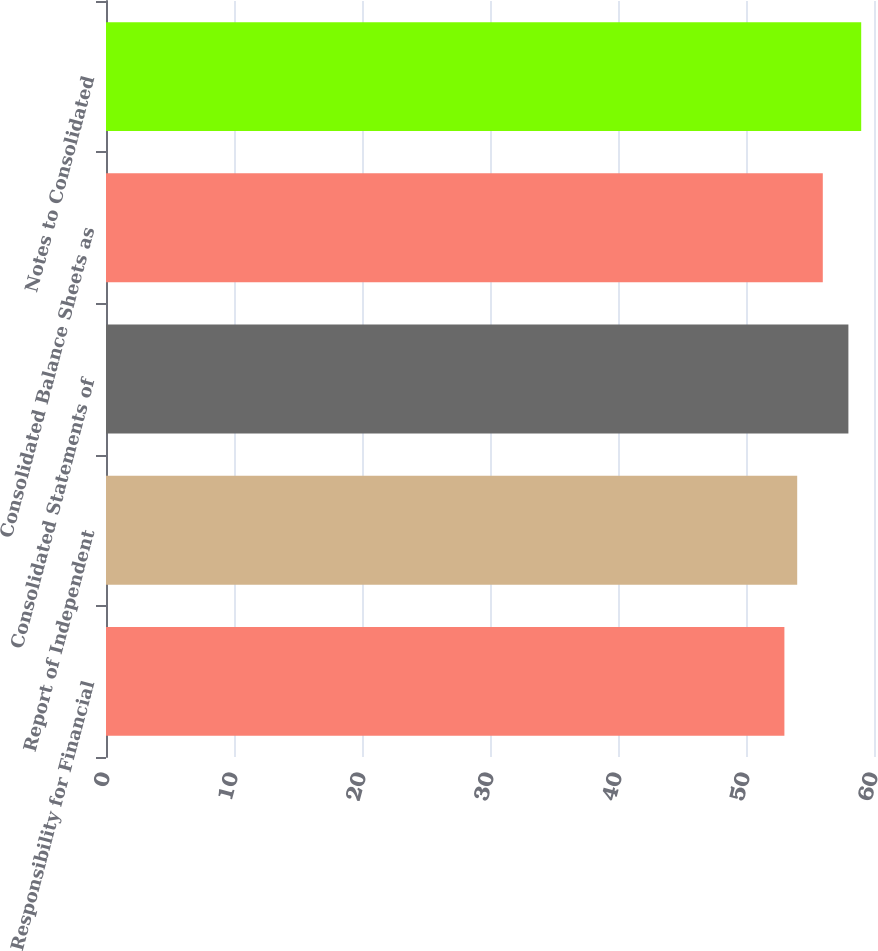<chart> <loc_0><loc_0><loc_500><loc_500><bar_chart><fcel>Responsibility for Financial<fcel>Report of Independent<fcel>Consolidated Statements of<fcel>Consolidated Balance Sheets as<fcel>Notes to Consolidated<nl><fcel>53<fcel>54<fcel>58<fcel>56<fcel>59<nl></chart> 